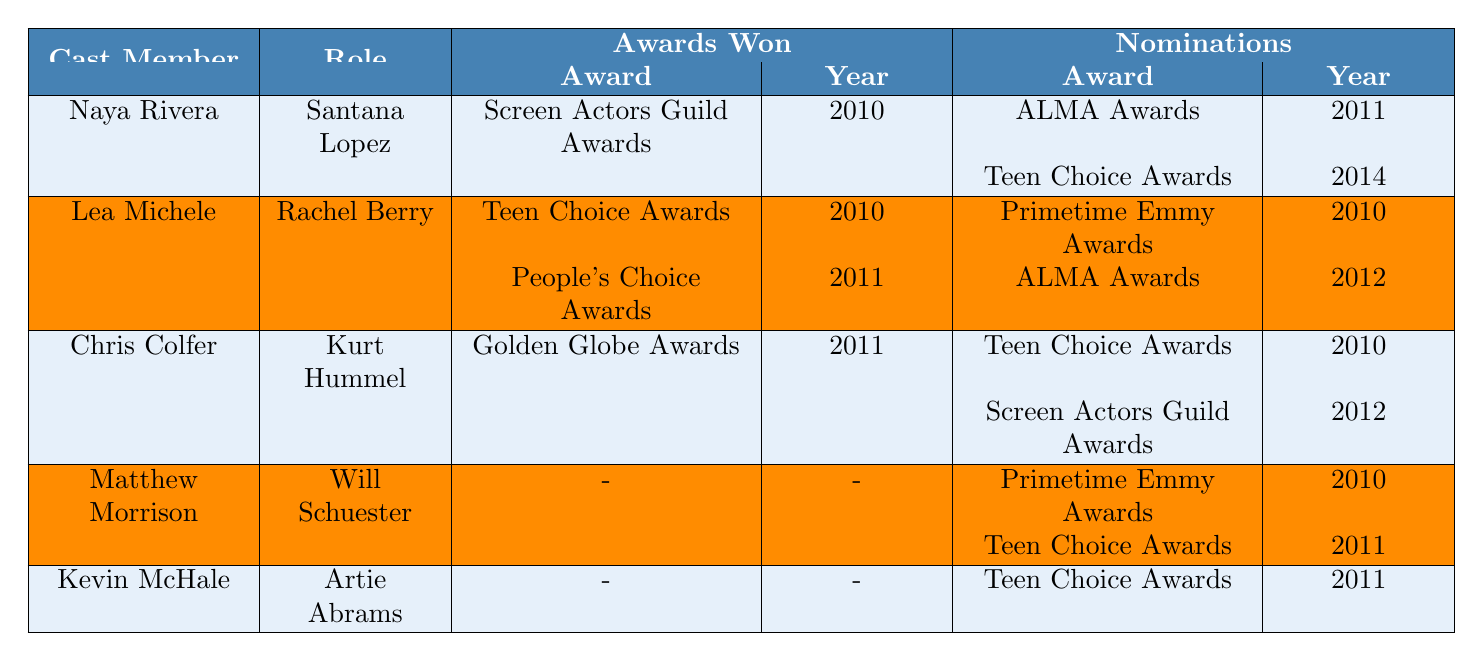What award did Naya Rivera win in 2010? According to the table, Naya Rivera won the Screen Actors Guild Award for Outstanding Performance by an Ensemble in a Comedy Series in 2010.
Answer: Screen Actors Guild Award How many awards did Kevin McHale win? The table shows that Kevin McHale has not won any awards, as indicated by the "-" in the "Awards Won" section for this cast member.
Answer: 0 Which cast member received a Golden Globe Award, and in what year? Chris Colfer received a Golden Globe Award for Best Supporting Actor in 2011, as stated in the "Awards Won" section of the table.
Answer: Chris Colfer, 2011 What is the total number of nominations received by Lea Michele? Lea Michele has two nominations listed: Primetime Emmy Awards (2010) and ALMA Awards (2012). Thus, the total is 2 nominations.
Answer: 2 Did Matthew Morrison win any awards during the series? The table indicates that Matthew Morrison did not win any awards, as shown by the "-" in the "Awards Won" section.
Answer: No Which year did Chris Colfer receive a nomination for the Teen Choice Awards? Chris Colfer was nominated for the Teen Choice Awards in 2010, which is specified in the "Nominations" section of the table.
Answer: 2010 Who received the most awards among the cast members listed? By comparing the awards won, Lea Michele and Naya Rivera each won one award, while Chris Colfer also won one. Matthew Morrison and Kevin McHale did not win any, thus there is a tie.
Answer: Tie between Naya Rivera, Lea Michele, and Chris Colfer How many total nominations does the entire cast have? Naya Rivera has 2, Lea Michele has 2, Chris Colfer has 2, Matthew Morrison has 2, and Kevin McHale has 1, giving a total of 2 + 2 + 2 + 2 + 1 = 9 nominations.
Answer: 9 Did any cast member receive a nomination for the Primetime Emmy Awards in 2010? Yes, Matthew Morrison received a nomination for the Primetime Emmy Awards in 2010, according to the "Nominations" section of the table.
Answer: Yes Which award was Chris Colfer nominated for in 2012? According to the table, Chris Colfer was nominated for the Screen Actors Guild Award for Outstanding Performance by an Ensemble in a Comedy Series in 2012.
Answer: Screen Actors Guild Award 